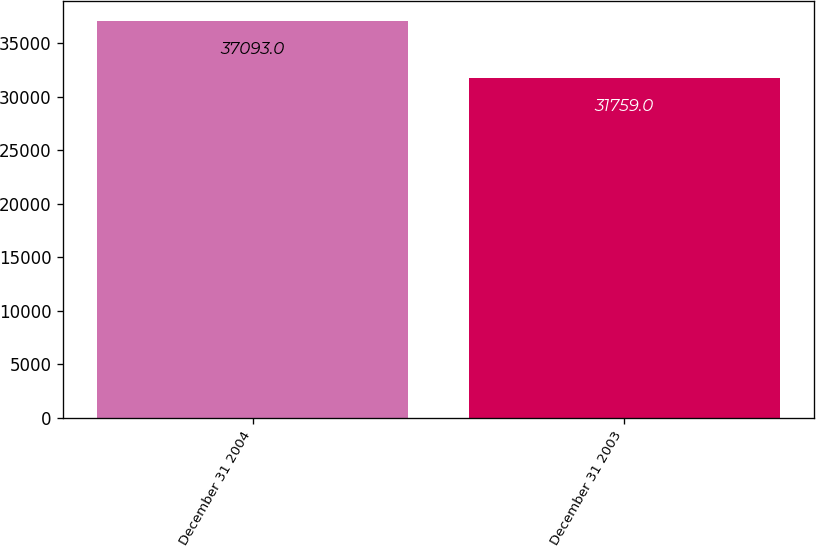<chart> <loc_0><loc_0><loc_500><loc_500><bar_chart><fcel>December 31 2004<fcel>December 31 2003<nl><fcel>37093<fcel>31759<nl></chart> 